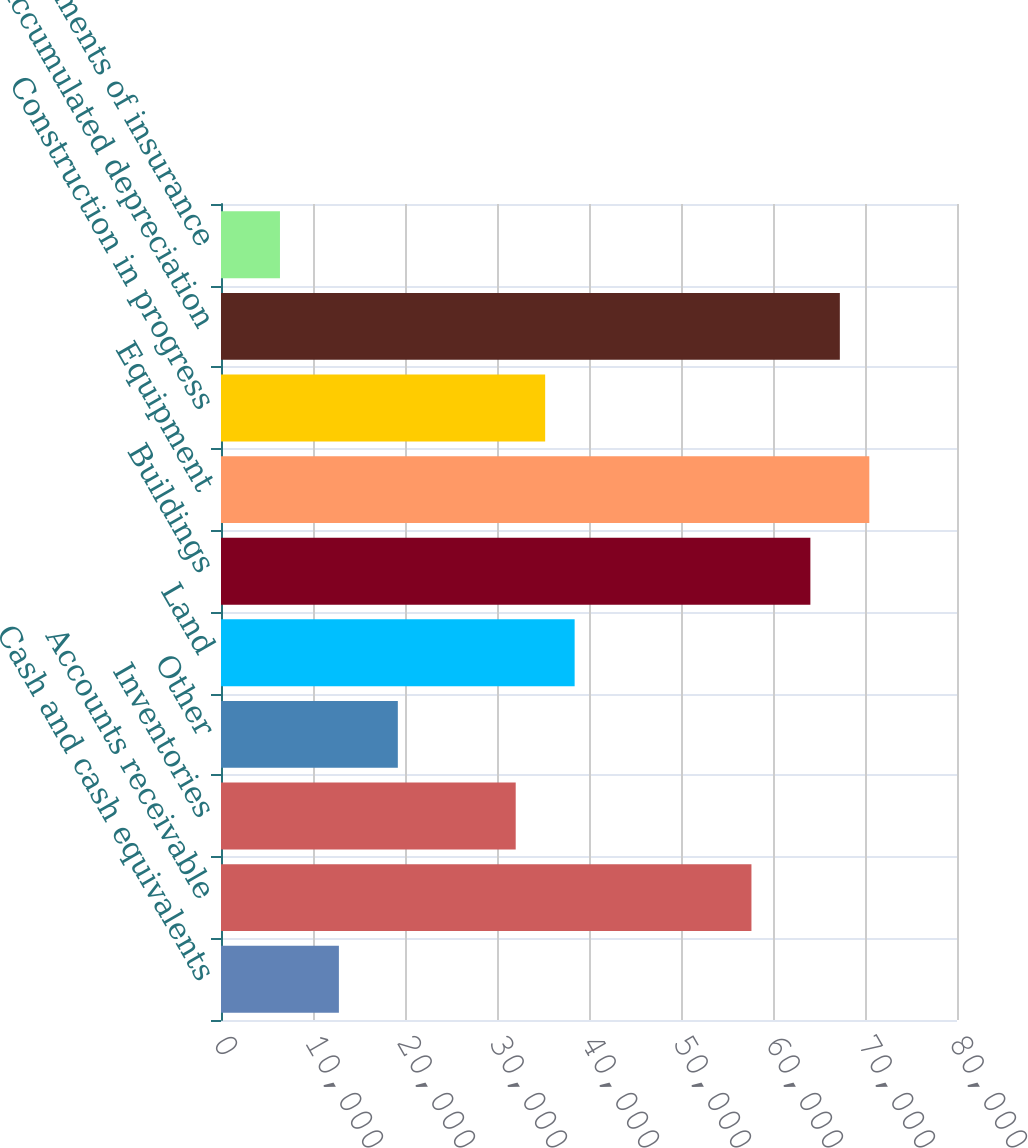Convert chart. <chart><loc_0><loc_0><loc_500><loc_500><bar_chart><fcel>Cash and cash equivalents<fcel>Accounts receivable<fcel>Inventories<fcel>Other<fcel>Land<fcel>Buildings<fcel>Equipment<fcel>Construction in progress<fcel>Accumulated depreciation<fcel>Investments of insurance<nl><fcel>12815<fcel>57657<fcel>32033<fcel>19221<fcel>38439<fcel>64063<fcel>70469<fcel>35236<fcel>67266<fcel>6409<nl></chart> 